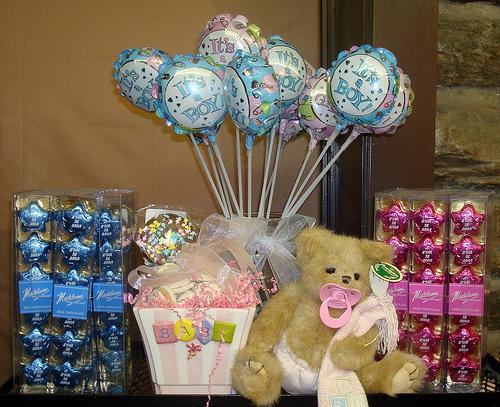Question: why do the balloons say 'it's a boy"?
Choices:
A. A baby boy was born.
B. The birth of a boy.
C. To celebrate a baby shower.
D. A boy has arrived.
Answer with the letter. Answer: C Question: who is in the picture?
Choices:
A. Baby shower decorations.
B. Girls.
C. Teachers.
D. Men.
Answer with the letter. Answer: A Question: what color are the stars on the right?
Choices:
A. Yellow.
B. Pink.
C. White.
D. Blue.
Answer with the letter. Answer: B Question: when is the photo taken?
Choices:
A. Nighttime.
B. Daytime.
C. At a baby shower.
D. Morning.
Answer with the letter. Answer: C 